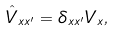<formula> <loc_0><loc_0><loc_500><loc_500>\hat { V } _ { x x ^ { \prime } } = \delta _ { x x ^ { \prime } } V _ { x } ,</formula> 